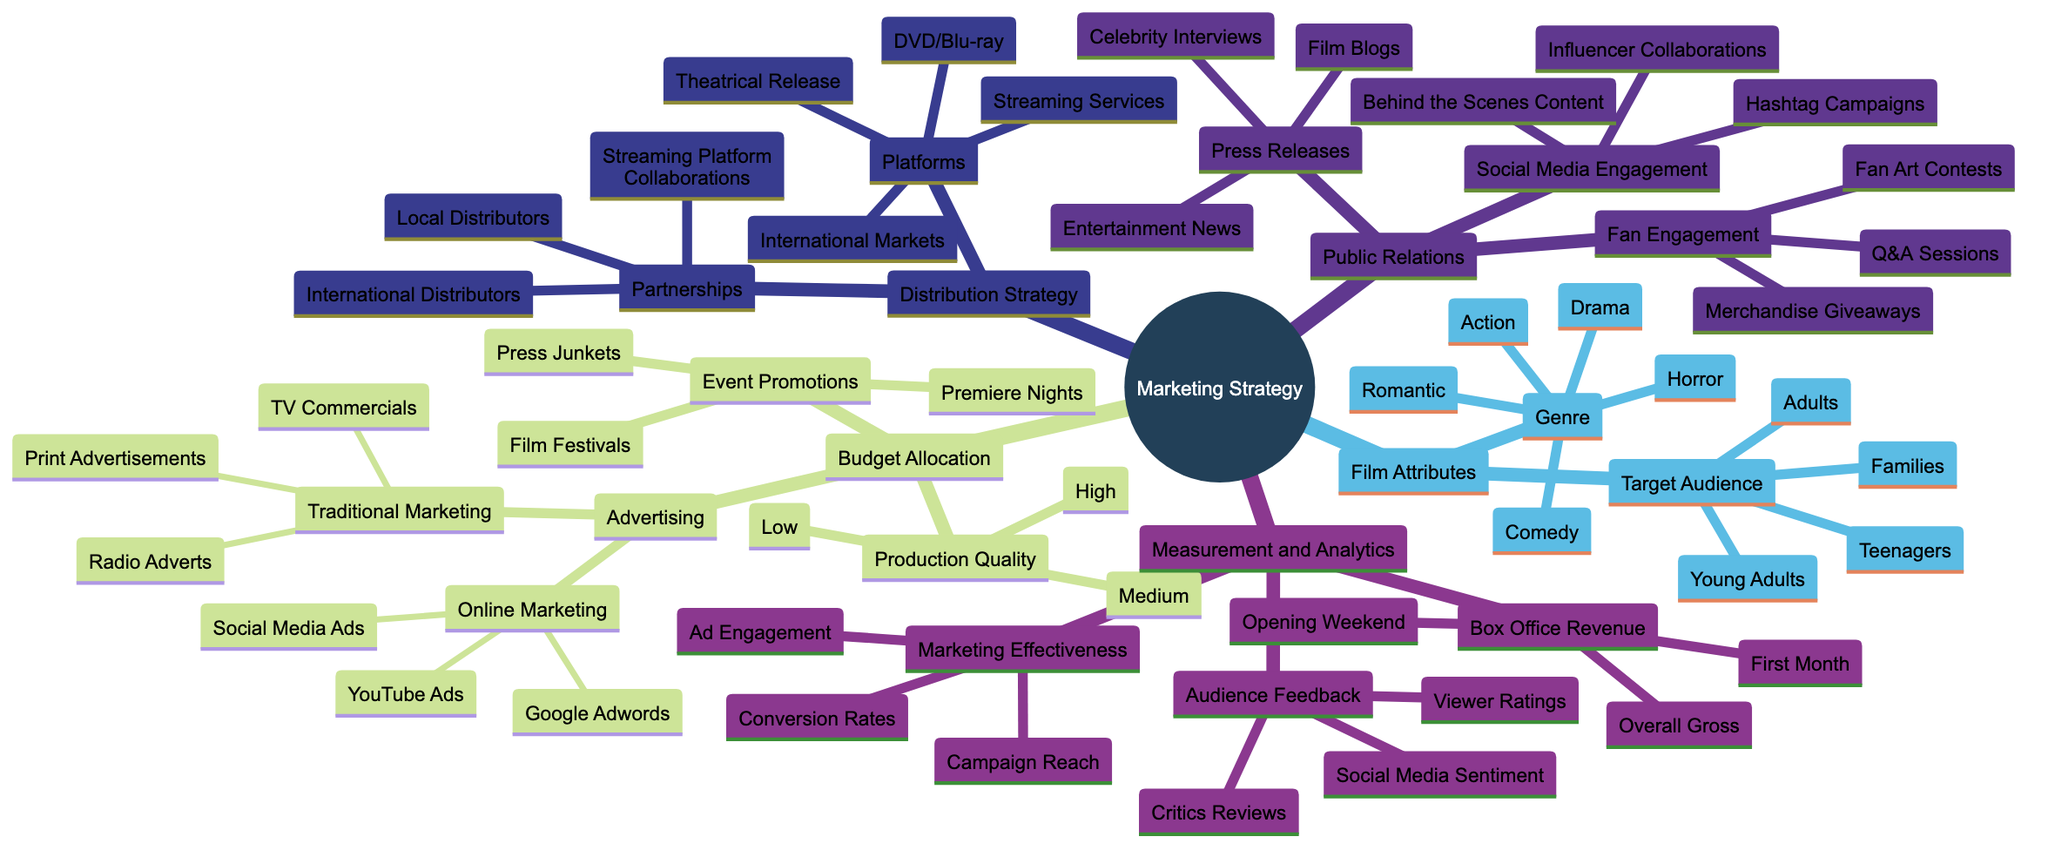What's the primary focus of the first branch in the diagram? The first branch labeled "Film Attributes" identifies key factors that impact the marketing strategy. This branch leads to specific categories such as "Genre" and "Target Audience."
Answer: Film Attributes How many genres are listed in the diagram? The "Genre" branch contains five distinct categories: Action, Drama, Comedy, Horror, and Romantic. Therefore, counting these categories gives us a total of five genres.
Answer: 5 What type of marketing does the "Online Marketing" node include? The "Online Marketing" category includes three specific methods: Social Media Ads, Google Adwords, and YouTube Ads. These are the distinct strategies under this node.
Answer: Social Media Ads, Google Adwords, YouTube Ads What is the relationship between "Event Promotions" and "Film Festivals"? "Event Promotions" is a parent category that leads to several promotional events, including Film Festivals. Therefore, Film Festivals is a specific type of Event Promotion.
Answer: Event Promotions --> Film Festivals If a film's target audience is "Families," what genres could potentially be matched with this choice? The target audience "Families" could correspond with several genres, particularly those that are family-friendly, such as Drama, Comedy, and Romantic. This allows for content that appeals broadly.
Answer: Drama, Comedy, Romantic What does the "Measurement and Analytics" branch assess? This branch evaluates the effectiveness of the marketing strategy by focusing on three main aspects: Box Office Revenue, Audience Feedback, and Marketing Effectiveness. Each of these assesses different performance metrics.
Answer: Box Office Revenue, Audience Feedback, Marketing Effectiveness How many types of press releases are outlined in the diagram? The "Press Releases" node enumerates three types: Entertainment News, Film Blogs, and Celebrity Interviews. So, there are three distinct types of press releases included in this category.
Answer: 3 Which node contains "Streaming Services" as part of its strategy? "Streaming Services" is categorized under the "Platforms" node in the "Distribution Strategy" section. This indicates that it is a method for distributing the film to audiences.
Answer: Platforms --> Streaming Services What is the overall goal of the "Distribution Strategy" section? The primary aim of the "Distribution Strategy" is to outline the methods and partnerships for effectively reaching the audience, specifically mentioning various platforms and distribution collaborations.
Answer: Distributing to audiences 